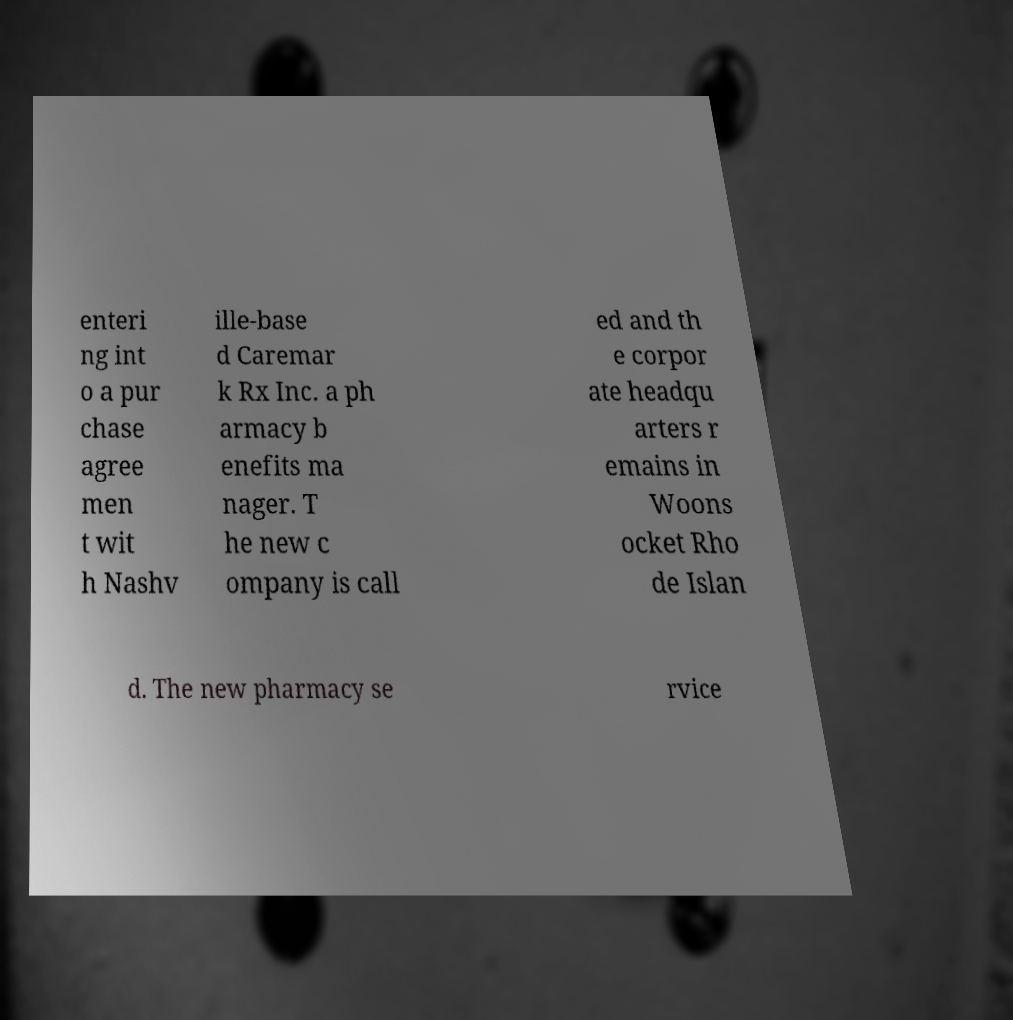There's text embedded in this image that I need extracted. Can you transcribe it verbatim? enteri ng int o a pur chase agree men t wit h Nashv ille-base d Caremar k Rx Inc. a ph armacy b enefits ma nager. T he new c ompany is call ed and th e corpor ate headqu arters r emains in Woons ocket Rho de Islan d. The new pharmacy se rvice 